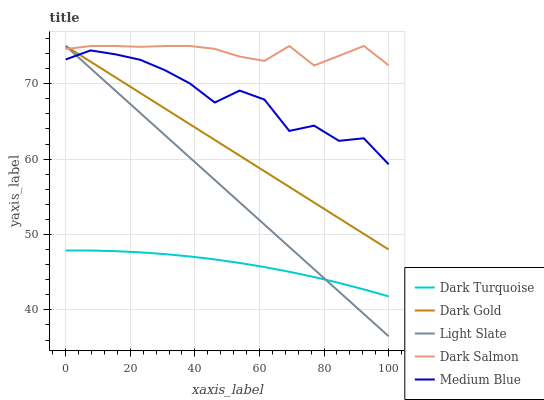Does Dark Turquoise have the minimum area under the curve?
Answer yes or no. Yes. Does Dark Salmon have the maximum area under the curve?
Answer yes or no. Yes. Does Medium Blue have the minimum area under the curve?
Answer yes or no. No. Does Medium Blue have the maximum area under the curve?
Answer yes or no. No. Is Light Slate the smoothest?
Answer yes or no. Yes. Is Medium Blue the roughest?
Answer yes or no. Yes. Is Dark Turquoise the smoothest?
Answer yes or no. No. Is Dark Turquoise the roughest?
Answer yes or no. No. Does Dark Turquoise have the lowest value?
Answer yes or no. No. Does Dark Gold have the highest value?
Answer yes or no. Yes. Does Medium Blue have the highest value?
Answer yes or no. No. Is Dark Turquoise less than Medium Blue?
Answer yes or no. Yes. Is Medium Blue greater than Dark Turquoise?
Answer yes or no. Yes. Does Dark Turquoise intersect Medium Blue?
Answer yes or no. No. 